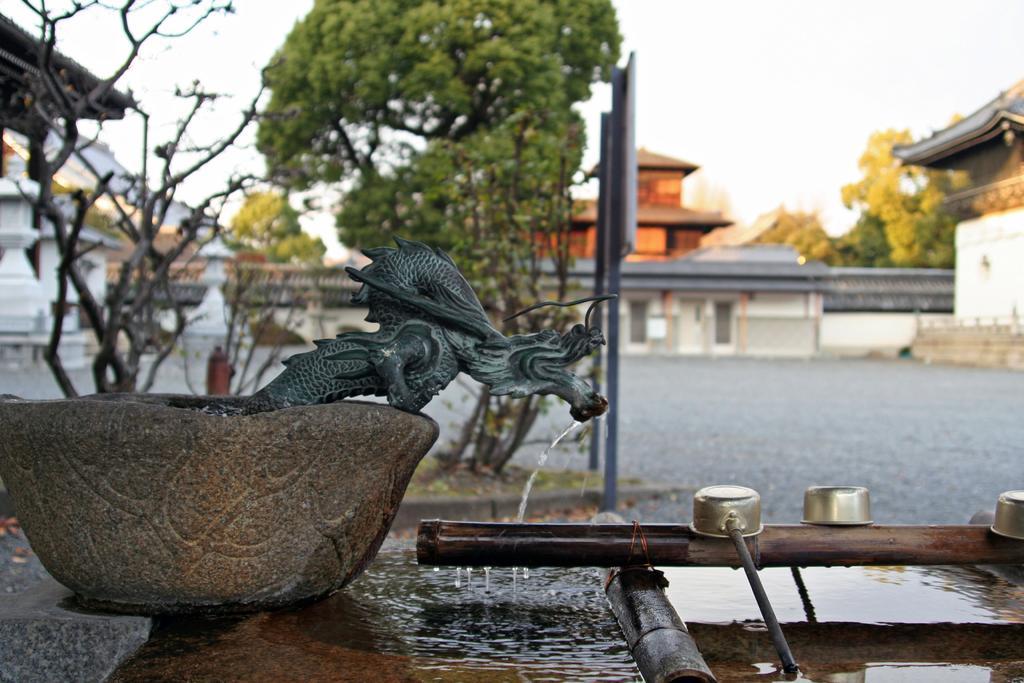Could you give a brief overview of what you see in this image? In this image there is a stone in the middle. On the stone there is a tap through which water is falling in the tub. In the background there are trees and houses. At the top there is sky. On the right side bottom there is a wooden stick on which there are three spoons. Under the wooden stick there is water. 